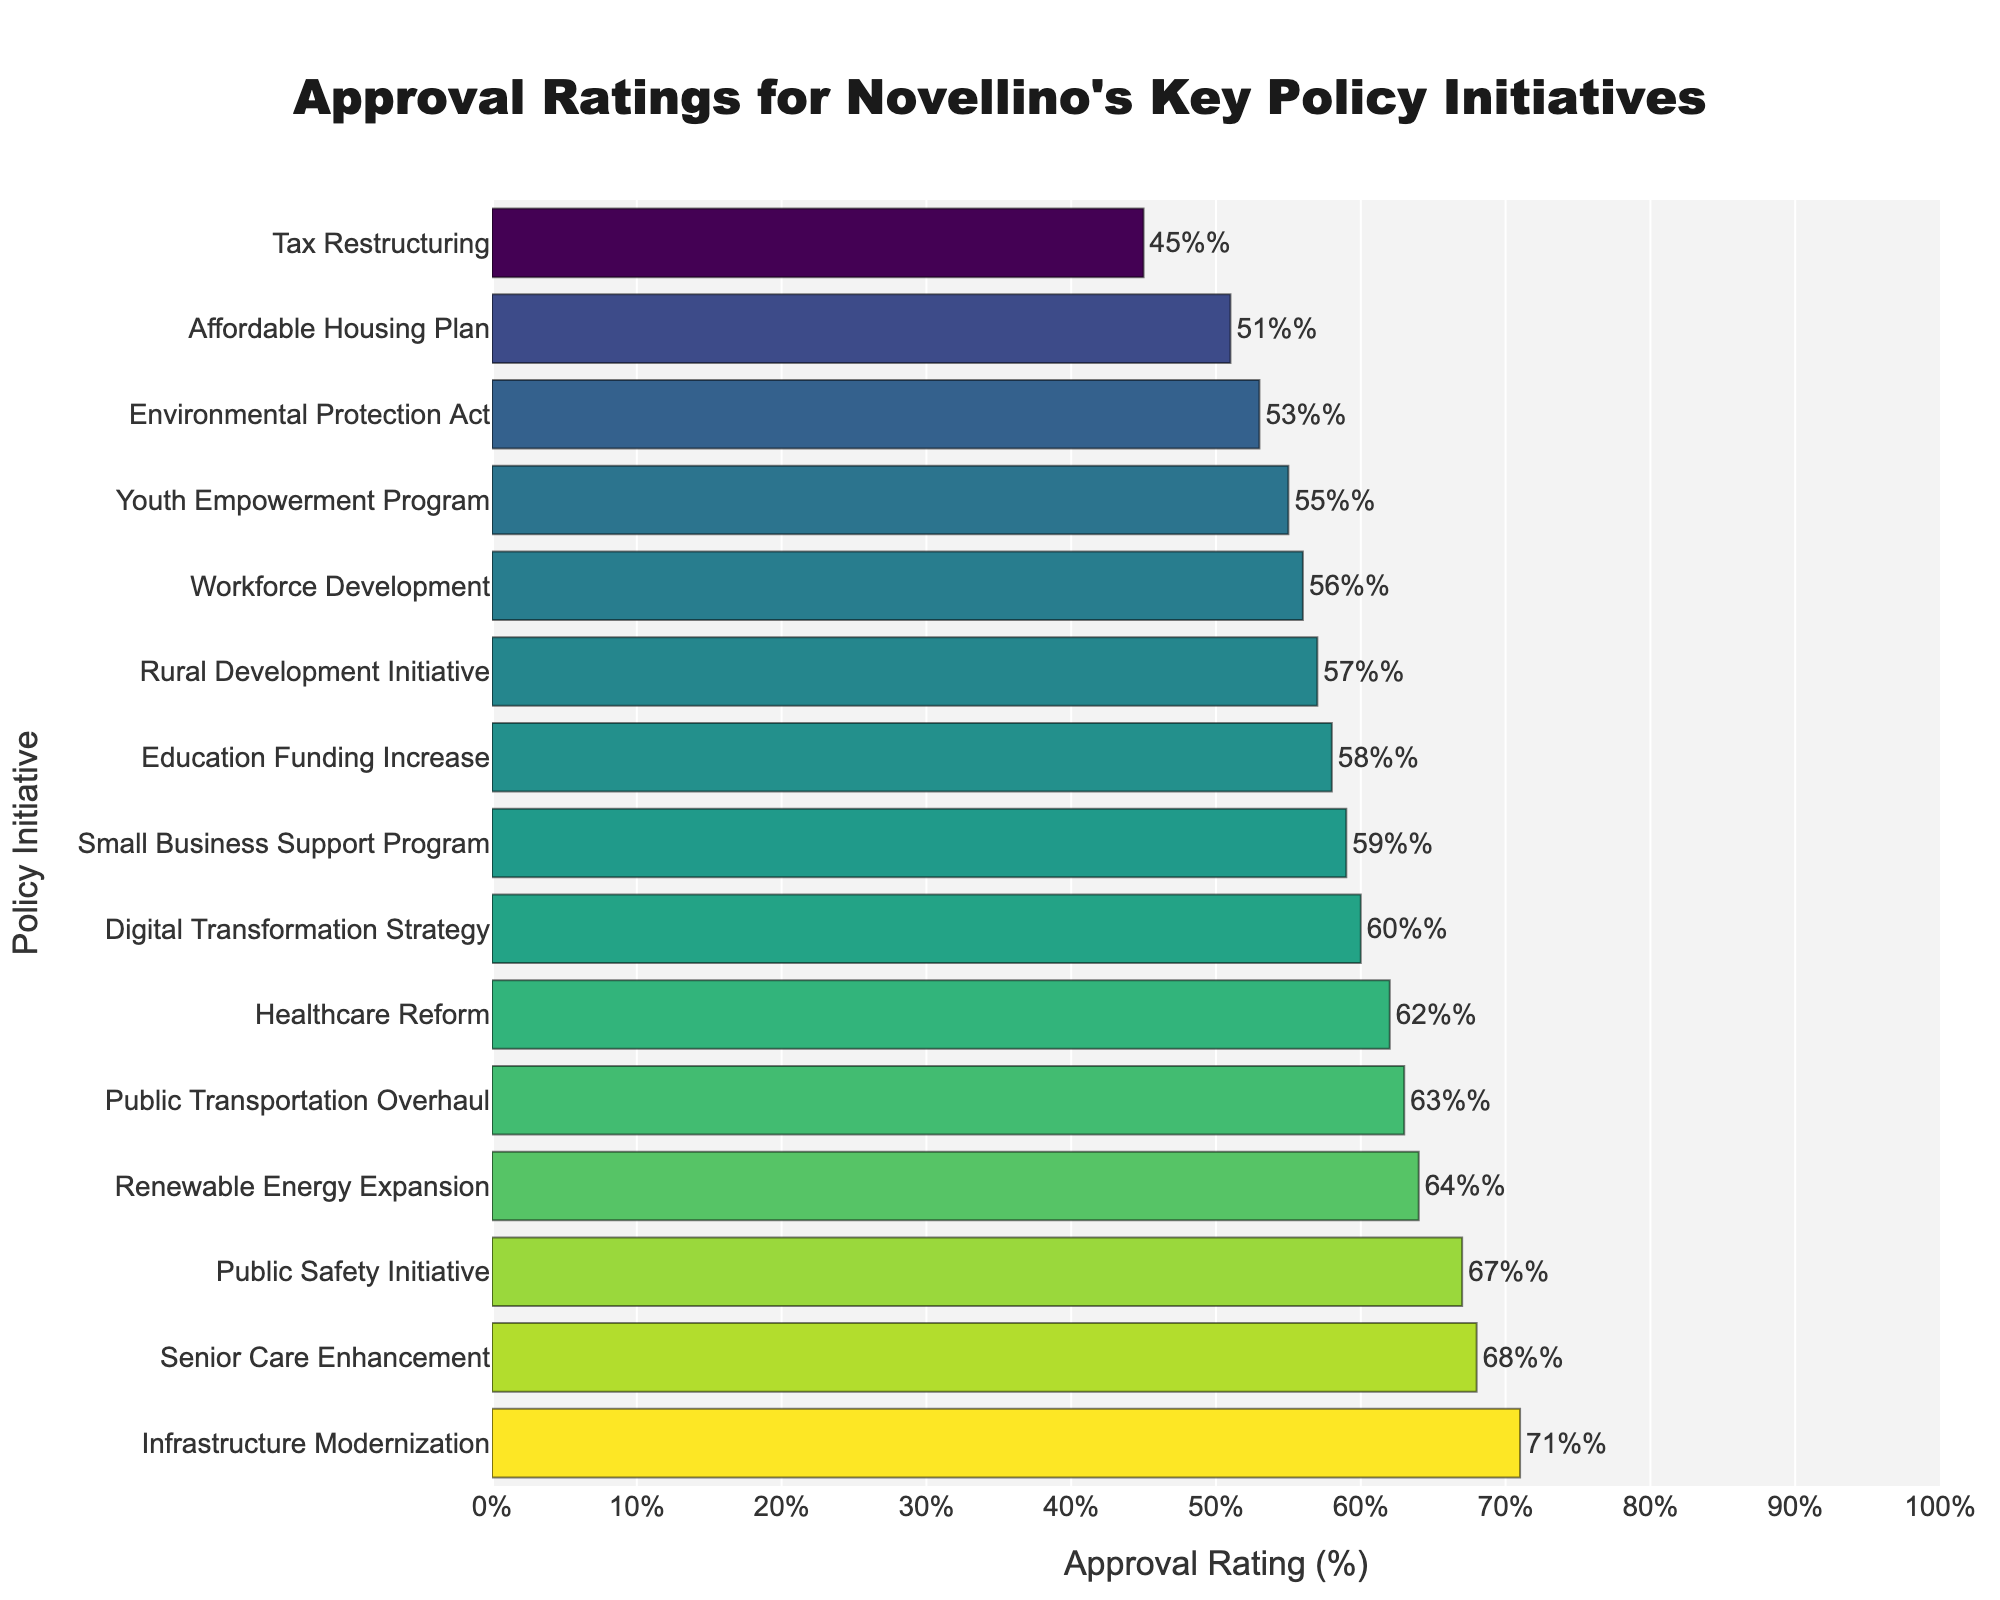Which policy initiative had the highest approval rating? The policy initiative with the highest bar in the bar chart indicates the highest approval rating. By checking the figure, we see that "Infrastructure Modernization" has the highest approval rating at 71%.
Answer: Infrastructure Modernization What is the difference in approval rating between the highest and lowest-rated policy initiatives? The highest approval rating is 71% (Infrastructure Modernization) and the lowest is 45% (Tax Restructuring). The difference is calculated as 71% - 45% = 26%.
Answer: 26% Which policy initiative had a higher approval rating: Education Funding Increase or Small Business Support Program? Compare the lengths of the two bars corresponding to "Education Funding Increase" and "Small Business Support Program" in the bar chart. "Small Business Support Program" has an approval rating of 59%, which is higher than "Education Funding Increase" at 58%.
Answer: Small Business Support Program How many policy initiatives have an approval rating of 60% or more? Count the bars with approval ratings equal to or greater than 60%. Those are Healthcare Reform (62%), Infrastructure Modernization (71%), Public Safety Initiative (67%), Renewable Energy Expansion (64%), Digital Transformation Strategy (60%), Senior Care Enhancement (68%), and Public Transportation Overhaul (63%), making a total of seven initiatives.
Answer: 7 What is the median approval rating across all policy initiatives? First, list all approval ratings in ascending order: 45, 51, 53, 55, 56, 57, 58, 59, 60, 62, 63, 64, 67, 68, 71. With 15 data points, the median is the 8th value. The 8th value is 59%, so the median approval rating is 59%.
Answer: 59% By how much does the Approval Rating of the Senior Care Enhancement exceed that of the Affordable Housing Plan? The approval rating for Senior Care Enhancement is 68%, and for the Affordable Housing Plan is 51%. The difference is calculated as 68% - 51% = 17%.
Answer: 17% What is the average approval rating of the four policy initiatives with the highest approval ratings? First, identify the four policies with the highest approval ratings: Infrastructure Modernization (71%), Senior Care Enhancement (68%), Public Safety Initiative (67%), and Renewable Energy Expansion (64%). Average these ratings: (71 + 68 + 67 + 64) / 4 = 270 / 4 = 67.5%.
Answer: 67.5% Which policy initiatives have approval ratings between 55% and 65%? Look for bars whose approval ratings fall within this range. The policy initiatives are Public Transportation Overhaul (63%), Digital Transformation Strategy (60%), Healthcare Reform (62%), Small Business Support Program (59%), Workforce Development (56%), Youth Empowerment Program (55%), and Environmental Protection Act (53%).
Answer: Public Transportation Overhaul, Digital Transformation Strategy, Healthcare Reform, Small Business Support Program, Workforce Development, Youth Empowerment Program, Environmental Protection Act 